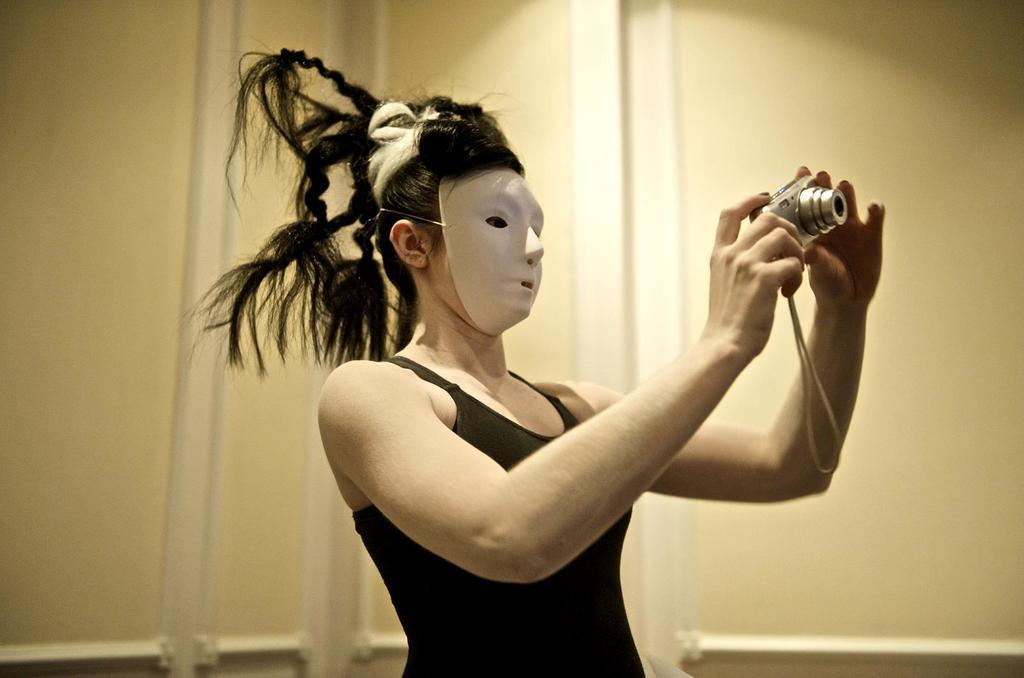What can be seen in the image? There is a person in the image. What is the person wearing on their face? The person is wearing a mask on their face. What is the person holding in their hands? The person is holding a camera in their hands. What is visible in the background of the image? There is a wall in the background of the image. What type of pain is the person experiencing in the image? There is no indication in the image that the person is experiencing any pain. Can you tell me how many elbows the person has in the image? The image only shows one person, and it is not possible to determine the number of elbows from the image alone. 